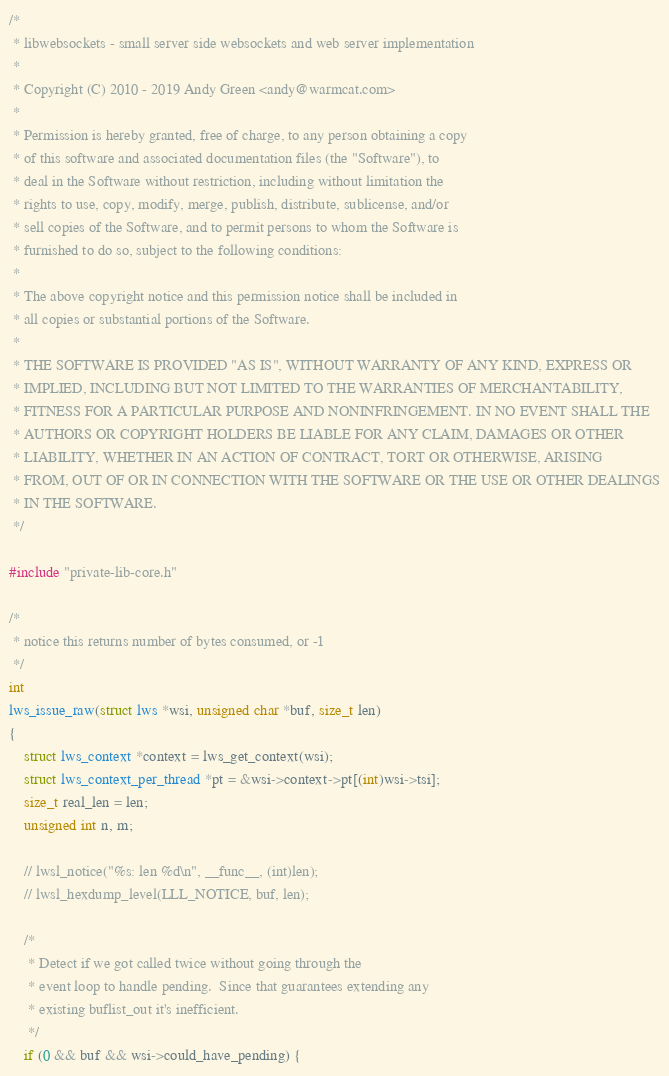Convert code to text. <code><loc_0><loc_0><loc_500><loc_500><_C_>/*
 * libwebsockets - small server side websockets and web server implementation
 *
 * Copyright (C) 2010 - 2019 Andy Green <andy@warmcat.com>
 *
 * Permission is hereby granted, free of charge, to any person obtaining a copy
 * of this software and associated documentation files (the "Software"), to
 * deal in the Software without restriction, including without limitation the
 * rights to use, copy, modify, merge, publish, distribute, sublicense, and/or
 * sell copies of the Software, and to permit persons to whom the Software is
 * furnished to do so, subject to the following conditions:
 *
 * The above copyright notice and this permission notice shall be included in
 * all copies or substantial portions of the Software.
 *
 * THE SOFTWARE IS PROVIDED "AS IS", WITHOUT WARRANTY OF ANY KIND, EXPRESS OR
 * IMPLIED, INCLUDING BUT NOT LIMITED TO THE WARRANTIES OF MERCHANTABILITY,
 * FITNESS FOR A PARTICULAR PURPOSE AND NONINFRINGEMENT. IN NO EVENT SHALL THE
 * AUTHORS OR COPYRIGHT HOLDERS BE LIABLE FOR ANY CLAIM, DAMAGES OR OTHER
 * LIABILITY, WHETHER IN AN ACTION OF CONTRACT, TORT OR OTHERWISE, ARISING
 * FROM, OUT OF OR IN CONNECTION WITH THE SOFTWARE OR THE USE OR OTHER DEALINGS
 * IN THE SOFTWARE.
 */

#include "private-lib-core.h"

/*
 * notice this returns number of bytes consumed, or -1
 */
int
lws_issue_raw(struct lws *wsi, unsigned char *buf, size_t len)
{
	struct lws_context *context = lws_get_context(wsi);
	struct lws_context_per_thread *pt = &wsi->context->pt[(int)wsi->tsi];
	size_t real_len = len;
	unsigned int n, m;

	// lwsl_notice("%s: len %d\n", __func__, (int)len);
	// lwsl_hexdump_level(LLL_NOTICE, buf, len);

	/*
	 * Detect if we got called twice without going through the
	 * event loop to handle pending.  Since that guarantees extending any
	 * existing buflist_out it's inefficient.
	 */
	if (0 && buf && wsi->could_have_pending) {</code> 